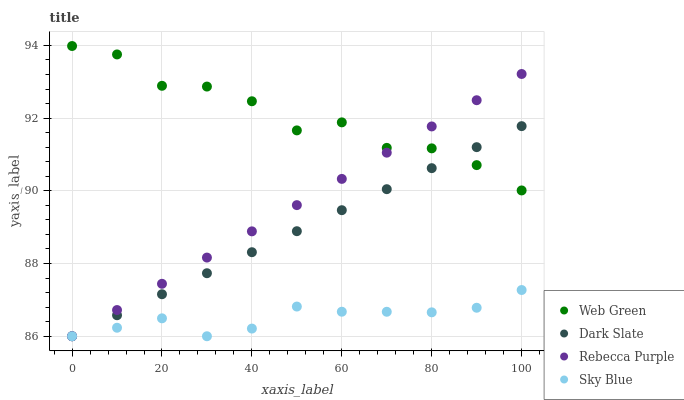Does Sky Blue have the minimum area under the curve?
Answer yes or no. Yes. Does Web Green have the maximum area under the curve?
Answer yes or no. Yes. Does Rebecca Purple have the minimum area under the curve?
Answer yes or no. No. Does Rebecca Purple have the maximum area under the curve?
Answer yes or no. No. Is Dark Slate the smoothest?
Answer yes or no. Yes. Is Web Green the roughest?
Answer yes or no. Yes. Is Rebecca Purple the smoothest?
Answer yes or no. No. Is Rebecca Purple the roughest?
Answer yes or no. No. Does Dark Slate have the lowest value?
Answer yes or no. Yes. Does Web Green have the lowest value?
Answer yes or no. No. Does Web Green have the highest value?
Answer yes or no. Yes. Does Rebecca Purple have the highest value?
Answer yes or no. No. Is Sky Blue less than Web Green?
Answer yes or no. Yes. Is Web Green greater than Sky Blue?
Answer yes or no. Yes. Does Dark Slate intersect Sky Blue?
Answer yes or no. Yes. Is Dark Slate less than Sky Blue?
Answer yes or no. No. Is Dark Slate greater than Sky Blue?
Answer yes or no. No. Does Sky Blue intersect Web Green?
Answer yes or no. No. 